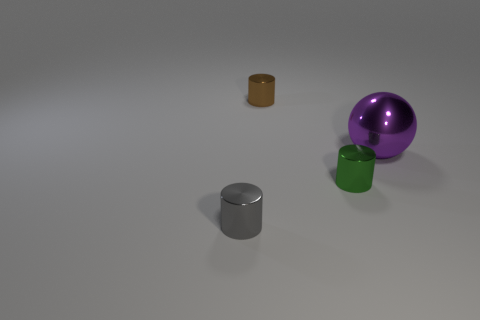Are there any other things that have the same shape as the big metallic object?
Keep it short and to the point. No. Are there any small gray metal cubes?
Ensure brevity in your answer.  No. There is a green object; does it have the same shape as the shiny thing in front of the green object?
Ensure brevity in your answer.  Yes. There is a tiny cylinder that is behind the small cylinder on the right side of the brown metal thing; what is its material?
Offer a very short reply. Metal. What is the color of the ball?
Provide a short and direct response. Purple. How many other spheres have the same color as the big metal ball?
Make the answer very short. 0. What number of things are either shiny objects in front of the purple thing or tiny brown metallic cylinders?
Make the answer very short. 3. The other large object that is made of the same material as the green thing is what color?
Ensure brevity in your answer.  Purple. Are there any green cylinders that have the same size as the gray cylinder?
Ensure brevity in your answer.  Yes. How many things are metal things left of the large purple ball or objects behind the gray metallic cylinder?
Your answer should be compact. 4. 